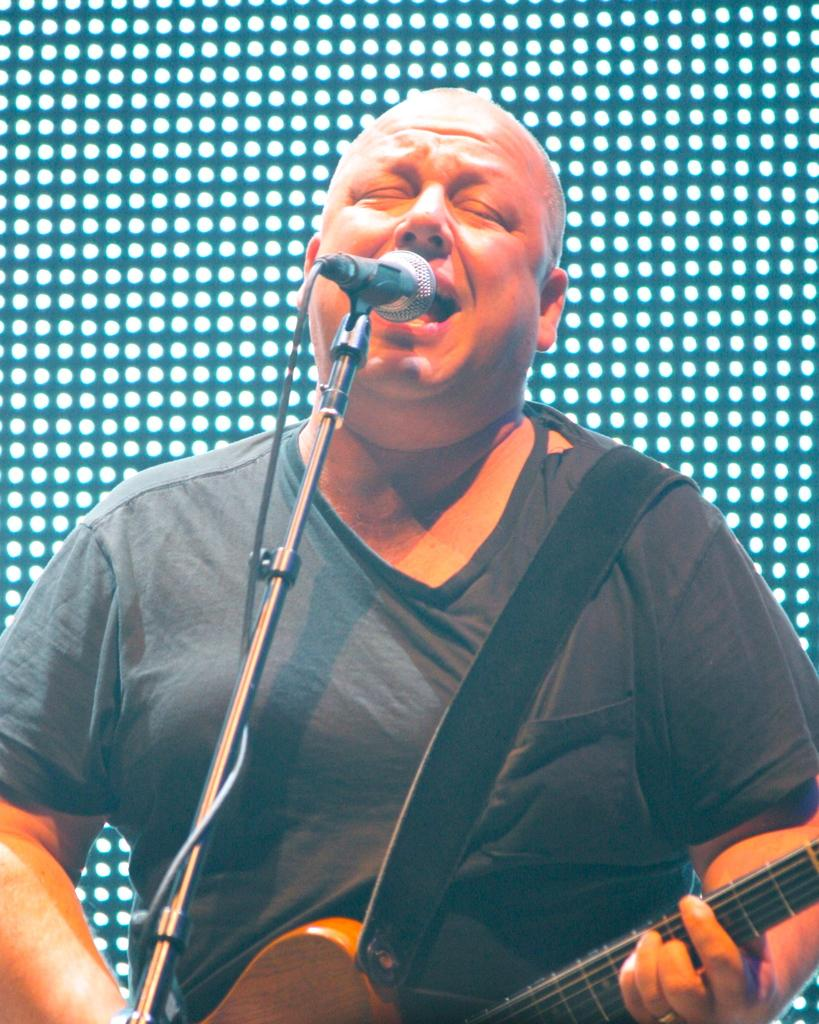Who is the main subject in the image? There is a man in the image. What is the man holding in the image? The man is holding a guitar. What is the man doing in the image? The man is singing. What is in front of the man that might be used for amplifying his voice? There is a microphone in front of the man. Can you see the man's parent in the image? There is no mention of a parent in the image, so it cannot be determined if the man's parent is present. 